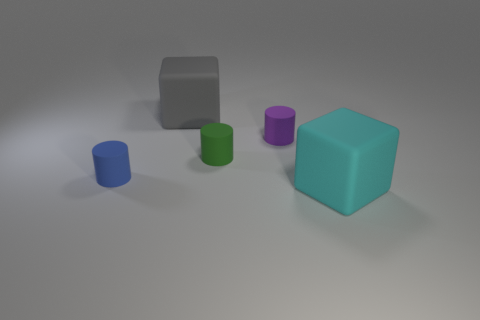What objects are present in the image, and what colors do they have? The image features a collection of geometric shapes. There's a small blue cylinder, a small green cylinder, a small purple cylinder, a medium-sized gray cube, and a large teal cube. Do these objects seem to have a particular texture? Yes, the objects appear to have a matte texture, which suggests they might be made of a material like plastic or rubber. 